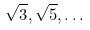<formula> <loc_0><loc_0><loc_500><loc_500>\sqrt { 3 } , \sqrt { 5 } , \dots</formula> 